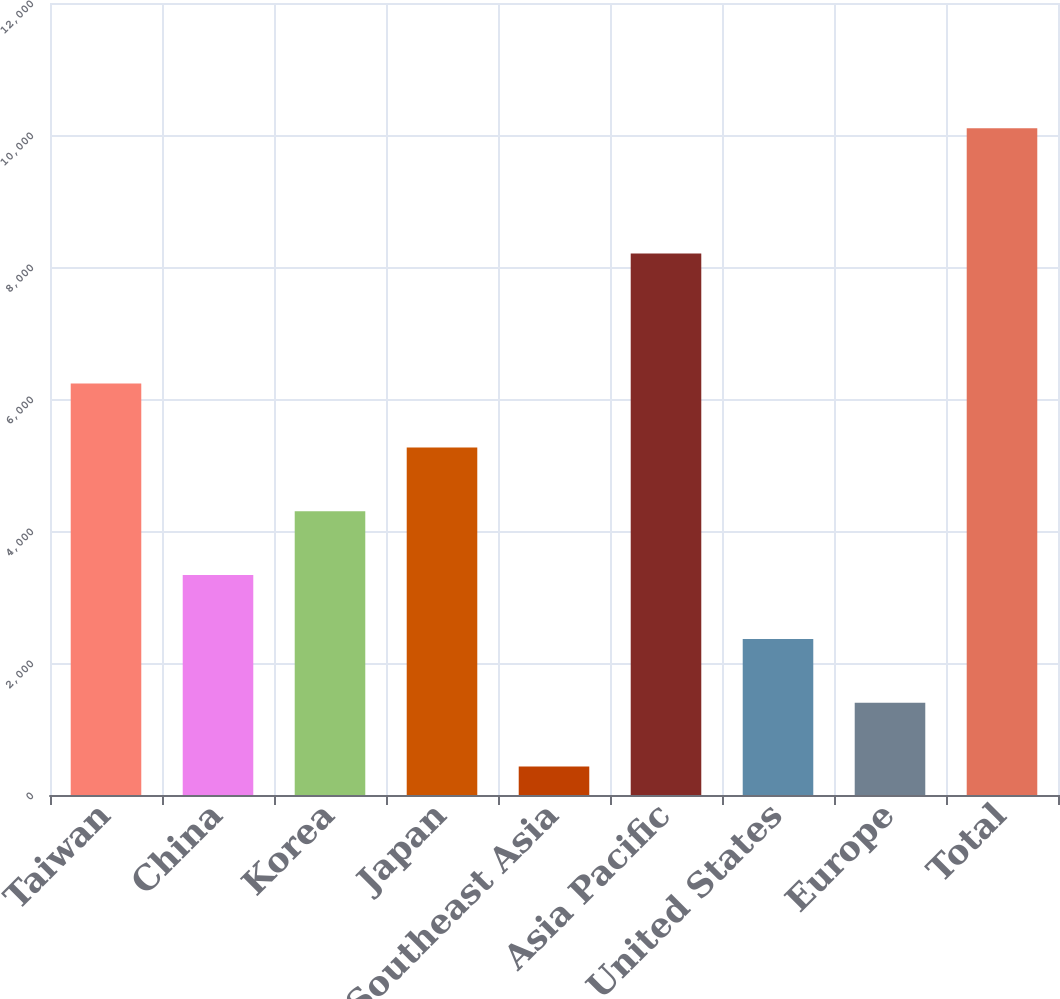<chart> <loc_0><loc_0><loc_500><loc_500><bar_chart><fcel>Taiwan<fcel>China<fcel>Korea<fcel>Japan<fcel>Southeast Asia<fcel>Asia Pacific<fcel>United States<fcel>Europe<fcel>Total<nl><fcel>6234.4<fcel>3332.2<fcel>4299.6<fcel>5267<fcel>430<fcel>8205<fcel>2364.8<fcel>1397.4<fcel>10104<nl></chart> 